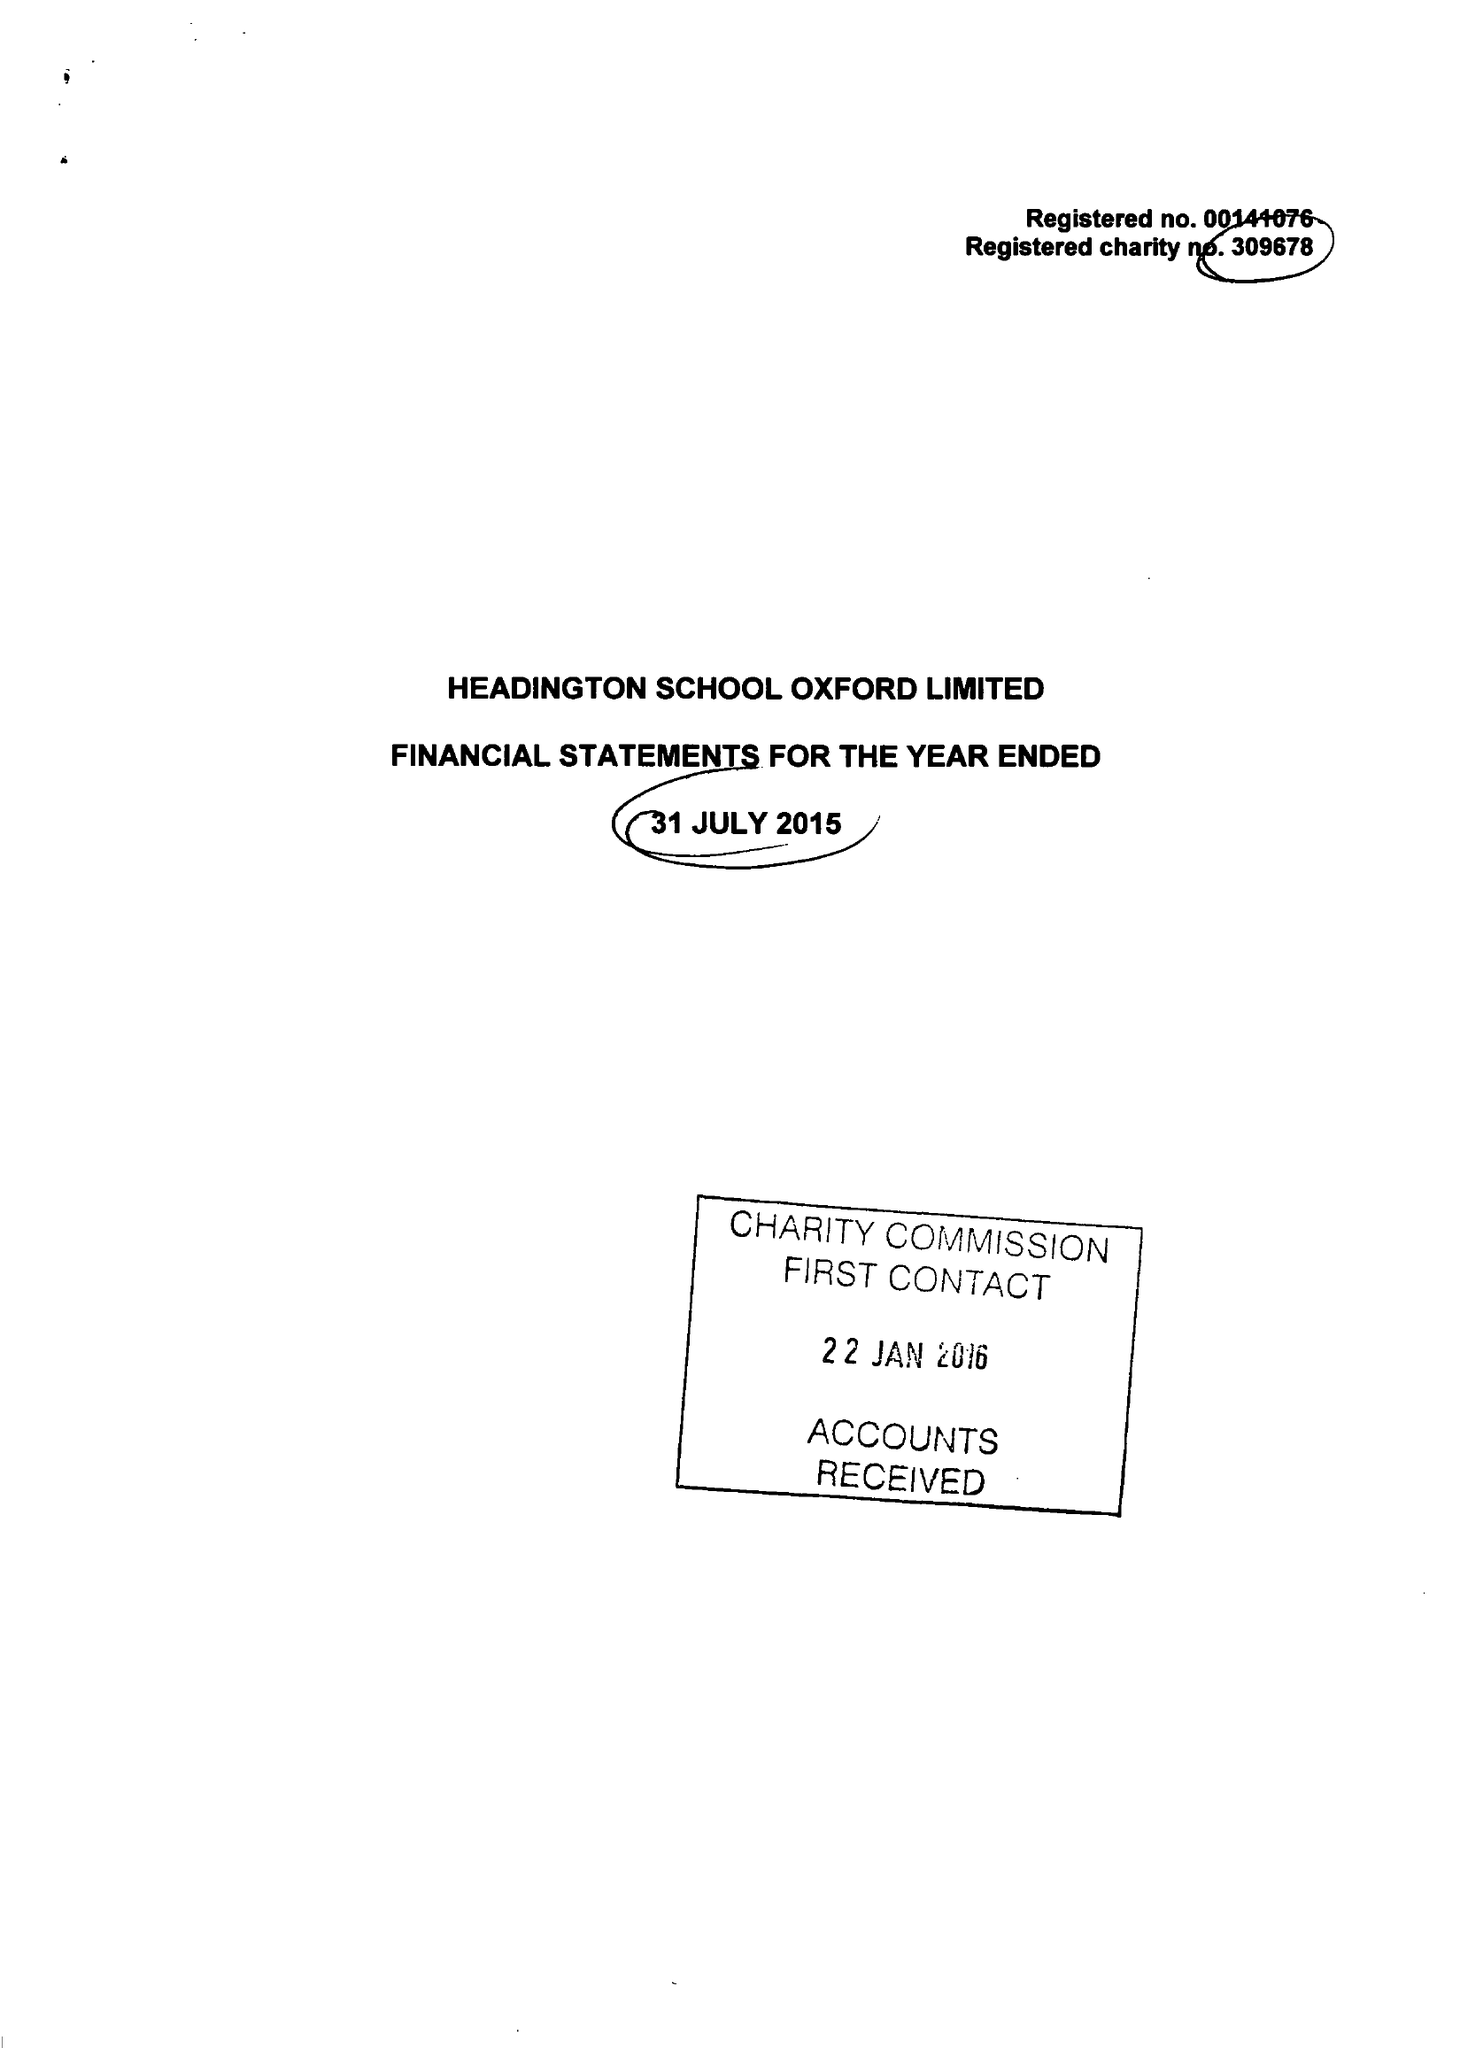What is the value for the spending_annually_in_british_pounds?
Answer the question using a single word or phrase. 17442521.00 